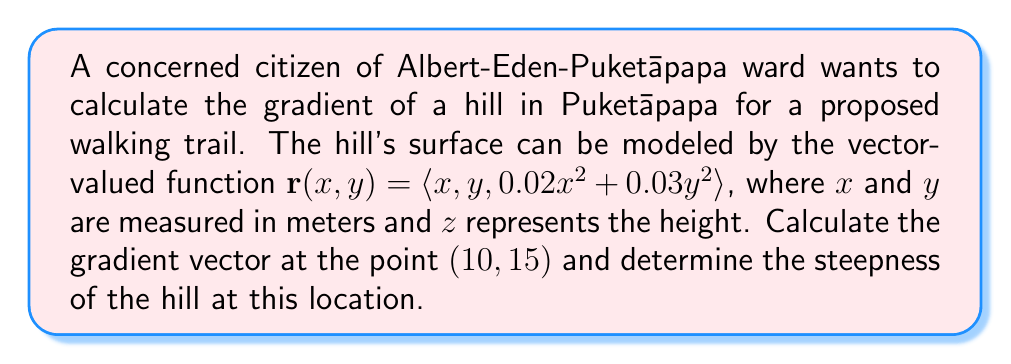Solve this math problem. To solve this problem, we'll follow these steps:

1) The gradient of a scalar-valued function $f(x,y)$ is defined as:

   $$\nabla f = \left\langle \frac{\partial f}{\partial x}, \frac{\partial f}{\partial y} \right\rangle$$

2) In our case, the height function is $z = f(x,y) = 0.02x^2 + 0.03y^2$

3) Let's calculate the partial derivatives:

   $$\frac{\partial f}{\partial x} = 0.04x$$
   $$\frac{\partial f}{\partial y} = 0.06y$$

4) Now we can form the gradient vector:

   $$\nabla f = \langle 0.04x, 0.06y \rangle$$

5) At the point (10, 15), the gradient vector is:

   $$\nabla f(10,15) = \langle 0.04(10), 0.06(15) \rangle = \langle 0.4, 0.9 \rangle$$

6) To find the steepness (magnitude of the gradient), we calculate:

   $$\|\nabla f(10,15)\| = \sqrt{(0.4)^2 + (0.9)^2} = \sqrt{0.16 + 0.81} = \sqrt{0.97} \approx 0.9849$$

7) This value represents the rate of change of height with respect to horizontal distance in the direction of steepest ascent. It can be interpreted as a rise/run ratio.

8) To express this as a percentage grade, we multiply by 100:

   Percentage grade $\approx 0.9849 * 100 \approx 98.49\%$
Answer: The gradient vector at the point (10, 15) is $\langle 0.4, 0.9 \rangle$, and the steepness of the hill at this location is approximately 0.9849 or 98.49%. 